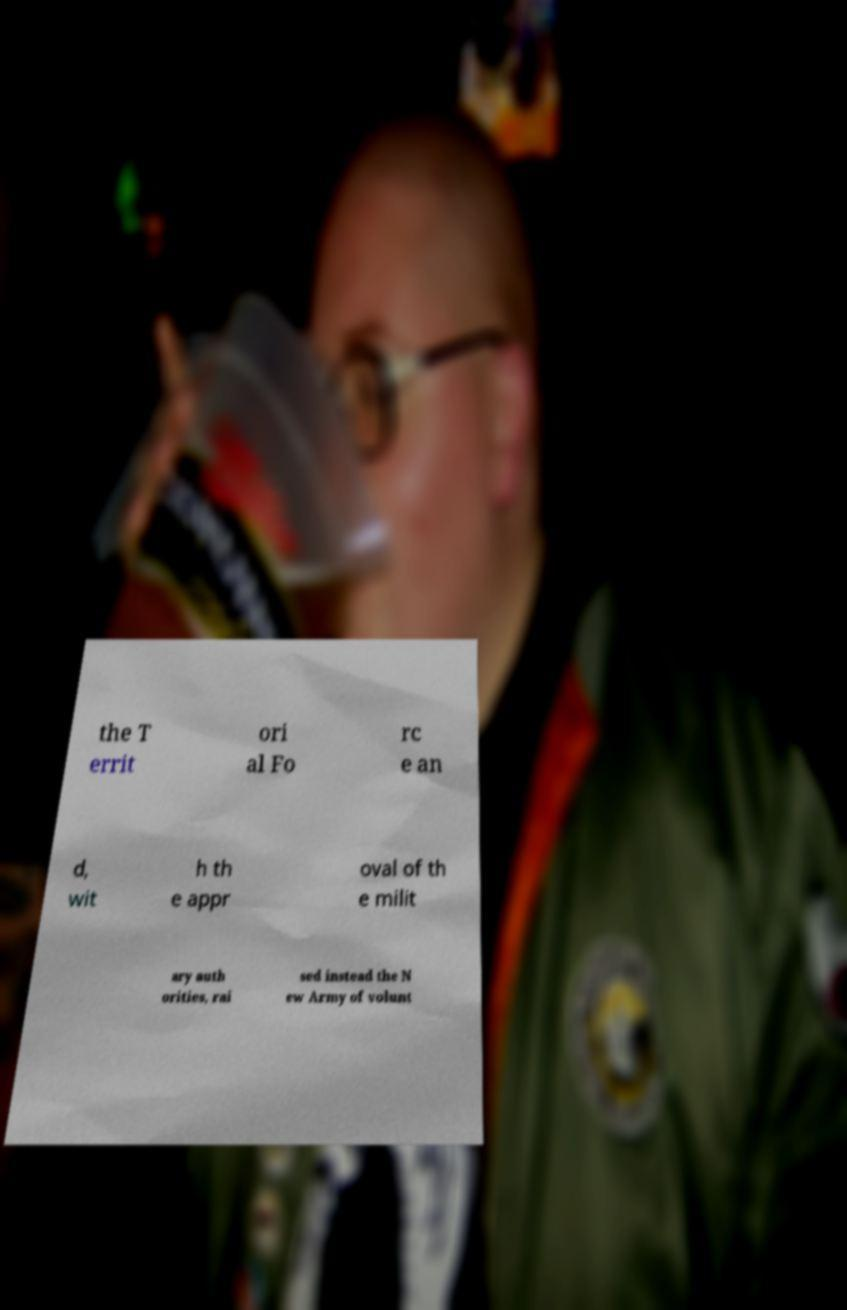Can you accurately transcribe the text from the provided image for me? the T errit ori al Fo rc e an d, wit h th e appr oval of th e milit ary auth orities, rai sed instead the N ew Army of volunt 